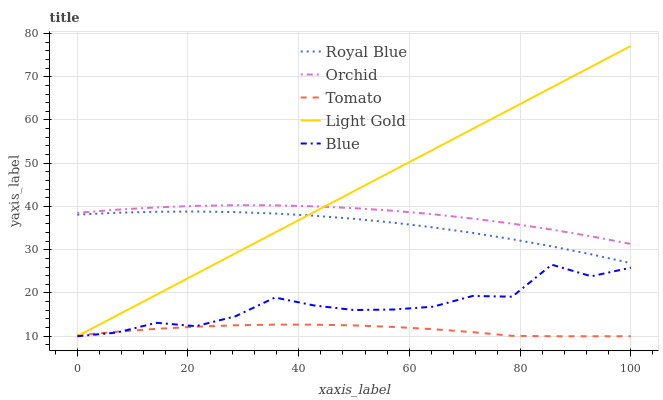Does Tomato have the minimum area under the curve?
Answer yes or no. Yes. Does Light Gold have the maximum area under the curve?
Answer yes or no. Yes. Does Royal Blue have the minimum area under the curve?
Answer yes or no. No. Does Royal Blue have the maximum area under the curve?
Answer yes or no. No. Is Light Gold the smoothest?
Answer yes or no. Yes. Is Blue the roughest?
Answer yes or no. Yes. Is Royal Blue the smoothest?
Answer yes or no. No. Is Royal Blue the roughest?
Answer yes or no. No. Does Tomato have the lowest value?
Answer yes or no. Yes. Does Royal Blue have the lowest value?
Answer yes or no. No. Does Light Gold have the highest value?
Answer yes or no. Yes. Does Royal Blue have the highest value?
Answer yes or no. No. Is Blue less than Orchid?
Answer yes or no. Yes. Is Orchid greater than Tomato?
Answer yes or no. Yes. Does Tomato intersect Blue?
Answer yes or no. Yes. Is Tomato less than Blue?
Answer yes or no. No. Is Tomato greater than Blue?
Answer yes or no. No. Does Blue intersect Orchid?
Answer yes or no. No. 